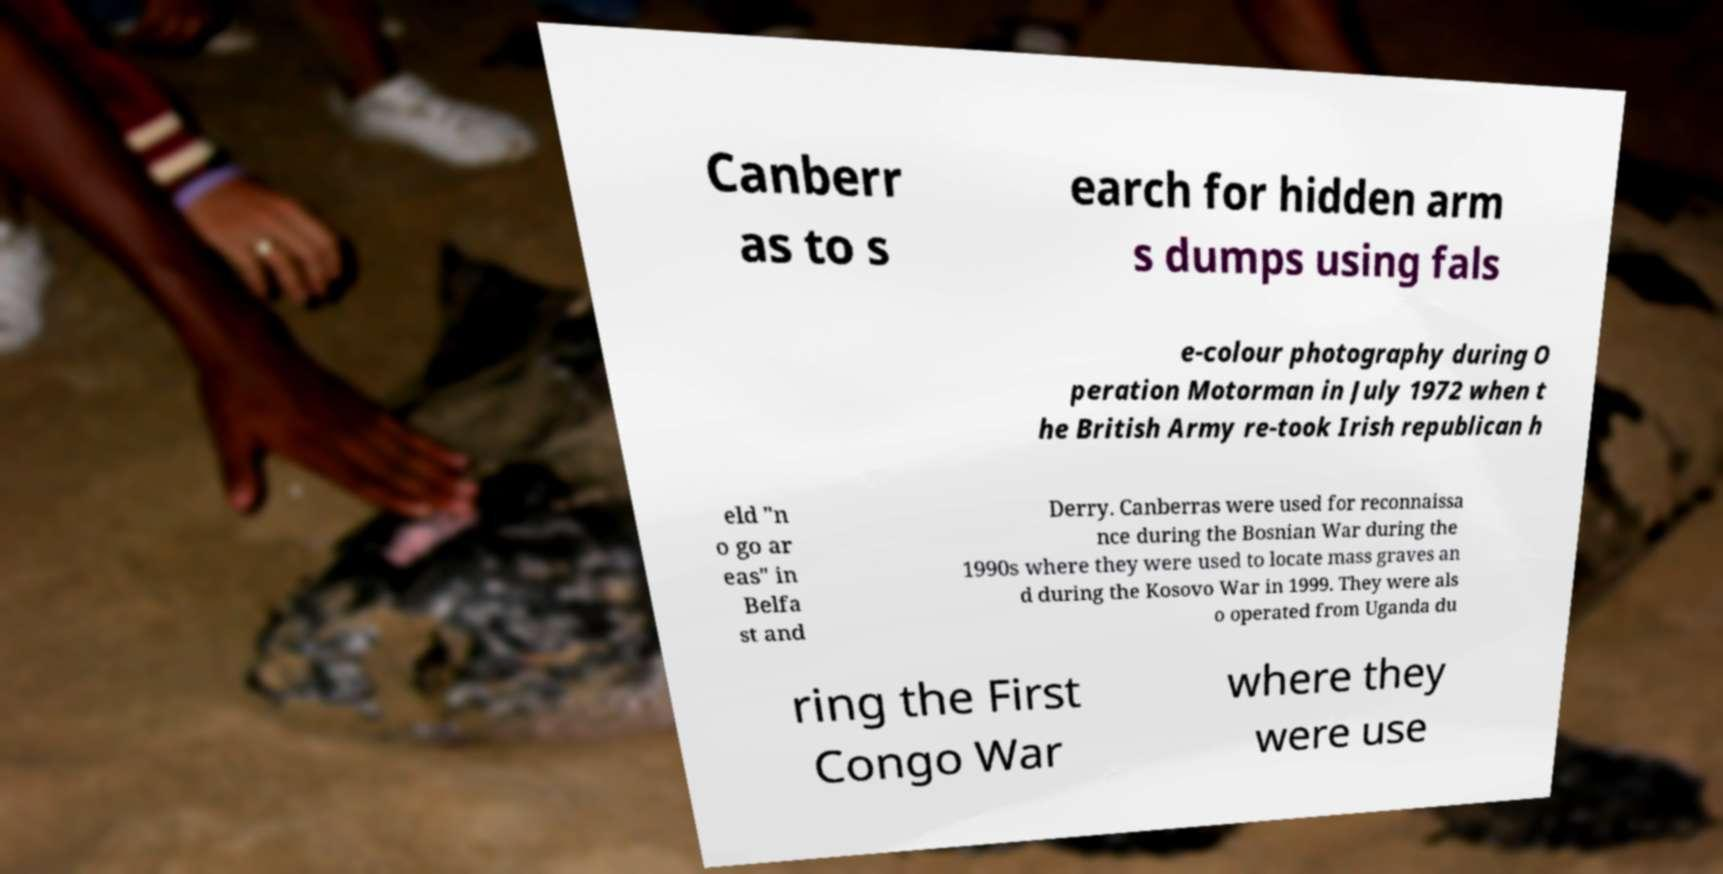Please read and relay the text visible in this image. What does it say? Canberr as to s earch for hidden arm s dumps using fals e-colour photography during O peration Motorman in July 1972 when t he British Army re-took Irish republican h eld "n o go ar eas" in Belfa st and Derry. Canberras were used for reconnaissa nce during the Bosnian War during the 1990s where they were used to locate mass graves an d during the Kosovo War in 1999. They were als o operated from Uganda du ring the First Congo War where they were use 